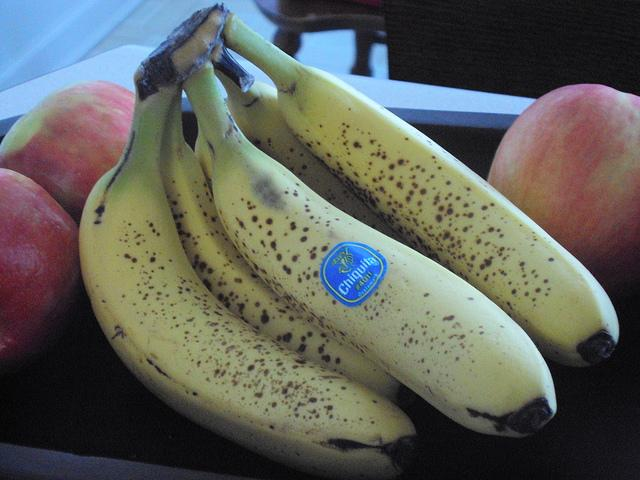Which fruit is too ripe? banana 